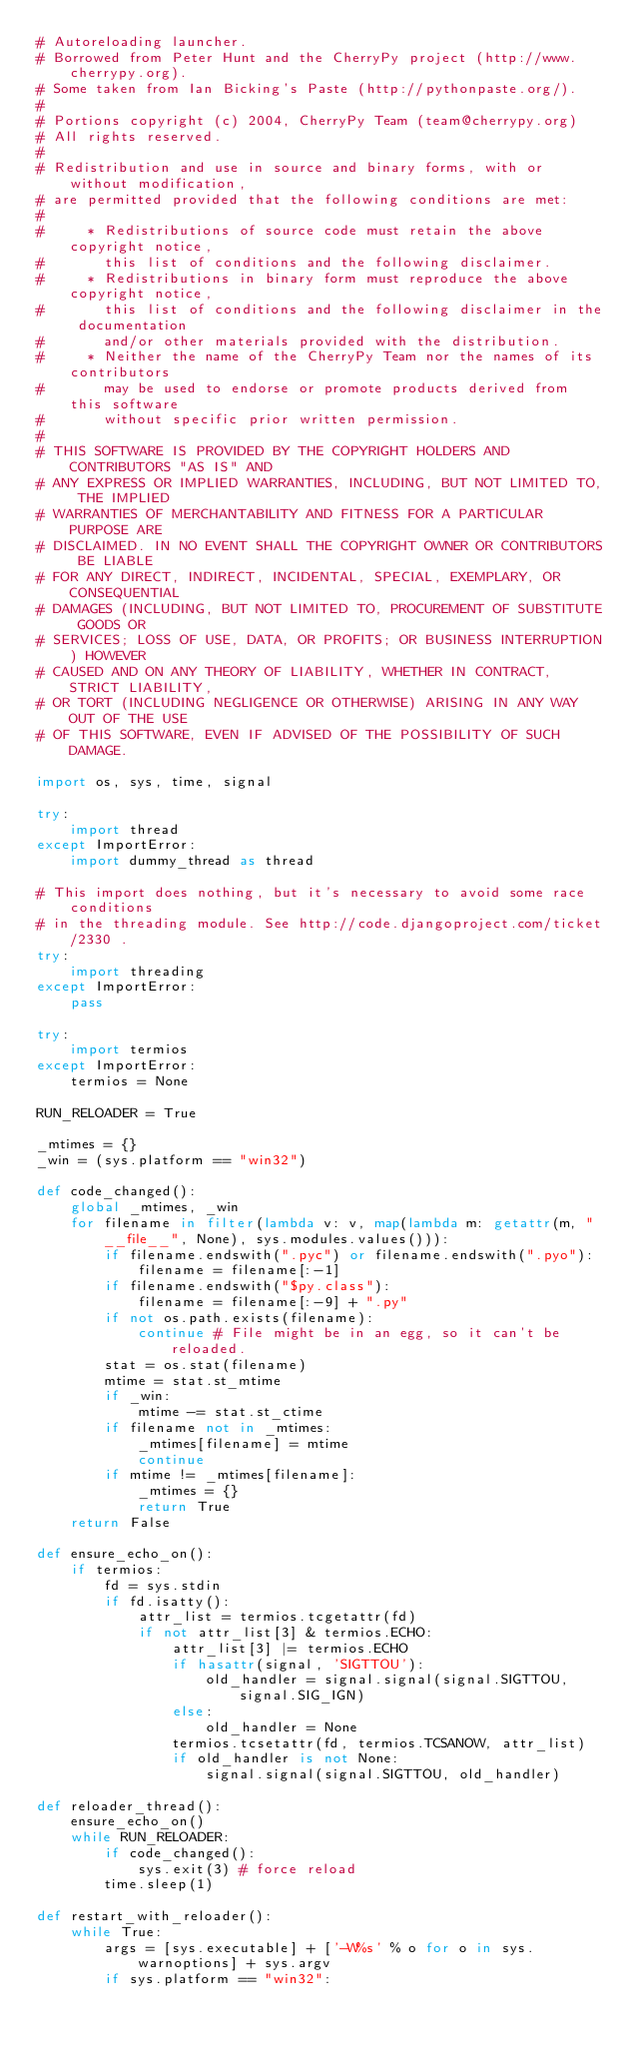Convert code to text. <code><loc_0><loc_0><loc_500><loc_500><_Python_># Autoreloading launcher.
# Borrowed from Peter Hunt and the CherryPy project (http://www.cherrypy.org).
# Some taken from Ian Bicking's Paste (http://pythonpaste.org/).
#
# Portions copyright (c) 2004, CherryPy Team (team@cherrypy.org)
# All rights reserved.
#
# Redistribution and use in source and binary forms, with or without modification,
# are permitted provided that the following conditions are met:
#
#     * Redistributions of source code must retain the above copyright notice,
#       this list of conditions and the following disclaimer.
#     * Redistributions in binary form must reproduce the above copyright notice,
#       this list of conditions and the following disclaimer in the documentation
#       and/or other materials provided with the distribution.
#     * Neither the name of the CherryPy Team nor the names of its contributors
#       may be used to endorse or promote products derived from this software
#       without specific prior written permission.
#
# THIS SOFTWARE IS PROVIDED BY THE COPYRIGHT HOLDERS AND CONTRIBUTORS "AS IS" AND
# ANY EXPRESS OR IMPLIED WARRANTIES, INCLUDING, BUT NOT LIMITED TO, THE IMPLIED
# WARRANTIES OF MERCHANTABILITY AND FITNESS FOR A PARTICULAR PURPOSE ARE
# DISCLAIMED. IN NO EVENT SHALL THE COPYRIGHT OWNER OR CONTRIBUTORS BE LIABLE
# FOR ANY DIRECT, INDIRECT, INCIDENTAL, SPECIAL, EXEMPLARY, OR CONSEQUENTIAL
# DAMAGES (INCLUDING, BUT NOT LIMITED TO, PROCUREMENT OF SUBSTITUTE GOODS OR
# SERVICES; LOSS OF USE, DATA, OR PROFITS; OR BUSINESS INTERRUPTION) HOWEVER
# CAUSED AND ON ANY THEORY OF LIABILITY, WHETHER IN CONTRACT, STRICT LIABILITY,
# OR TORT (INCLUDING NEGLIGENCE OR OTHERWISE) ARISING IN ANY WAY OUT OF THE USE
# OF THIS SOFTWARE, EVEN IF ADVISED OF THE POSSIBILITY OF SUCH DAMAGE.

import os, sys, time, signal

try:
    import thread
except ImportError:
    import dummy_thread as thread

# This import does nothing, but it's necessary to avoid some race conditions
# in the threading module. See http://code.djangoproject.com/ticket/2330 .
try:
    import threading
except ImportError:
    pass

try:
    import termios
except ImportError:
    termios = None

RUN_RELOADER = True

_mtimes = {}
_win = (sys.platform == "win32")

def code_changed():
    global _mtimes, _win
    for filename in filter(lambda v: v, map(lambda m: getattr(m, "__file__", None), sys.modules.values())):
        if filename.endswith(".pyc") or filename.endswith(".pyo"):
            filename = filename[:-1]
        if filename.endswith("$py.class"):
            filename = filename[:-9] + ".py"
        if not os.path.exists(filename):
            continue # File might be in an egg, so it can't be reloaded.
        stat = os.stat(filename)
        mtime = stat.st_mtime
        if _win:
            mtime -= stat.st_ctime
        if filename not in _mtimes:
            _mtimes[filename] = mtime
            continue
        if mtime != _mtimes[filename]:
            _mtimes = {}
            return True
    return False

def ensure_echo_on():
    if termios:
        fd = sys.stdin
        if fd.isatty():
            attr_list = termios.tcgetattr(fd)
            if not attr_list[3] & termios.ECHO:
                attr_list[3] |= termios.ECHO
                if hasattr(signal, 'SIGTTOU'):
                    old_handler = signal.signal(signal.SIGTTOU, signal.SIG_IGN)
                else:
                    old_handler = None
                termios.tcsetattr(fd, termios.TCSANOW, attr_list)
                if old_handler is not None:
                    signal.signal(signal.SIGTTOU, old_handler)

def reloader_thread():
    ensure_echo_on()
    while RUN_RELOADER:
        if code_changed():
            sys.exit(3) # force reload
        time.sleep(1)

def restart_with_reloader():
    while True:
        args = [sys.executable] + ['-W%s' % o for o in sys.warnoptions] + sys.argv
        if sys.platform == "win32":</code> 